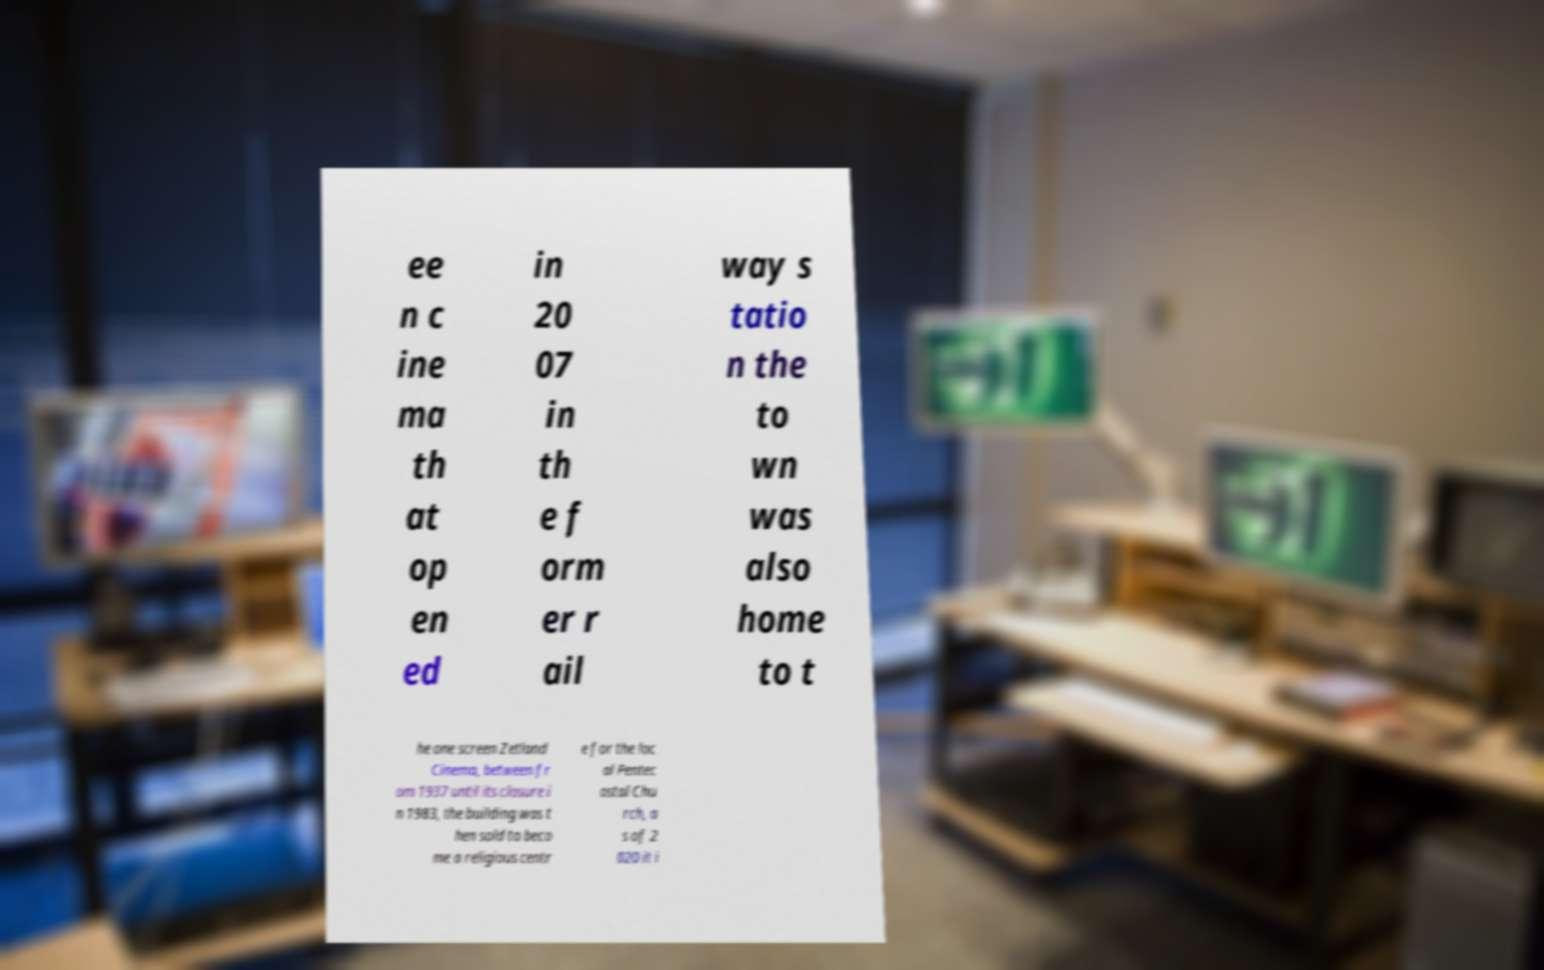Please identify and transcribe the text found in this image. ee n c ine ma th at op en ed in 20 07 in th e f orm er r ail way s tatio n the to wn was also home to t he one screen Zetland Cinema, between fr om 1937 until its closure i n 1983, the building was t hen sold to beco me a religious centr e for the loc al Pentec ostal Chu rch, a s of 2 020 it i 